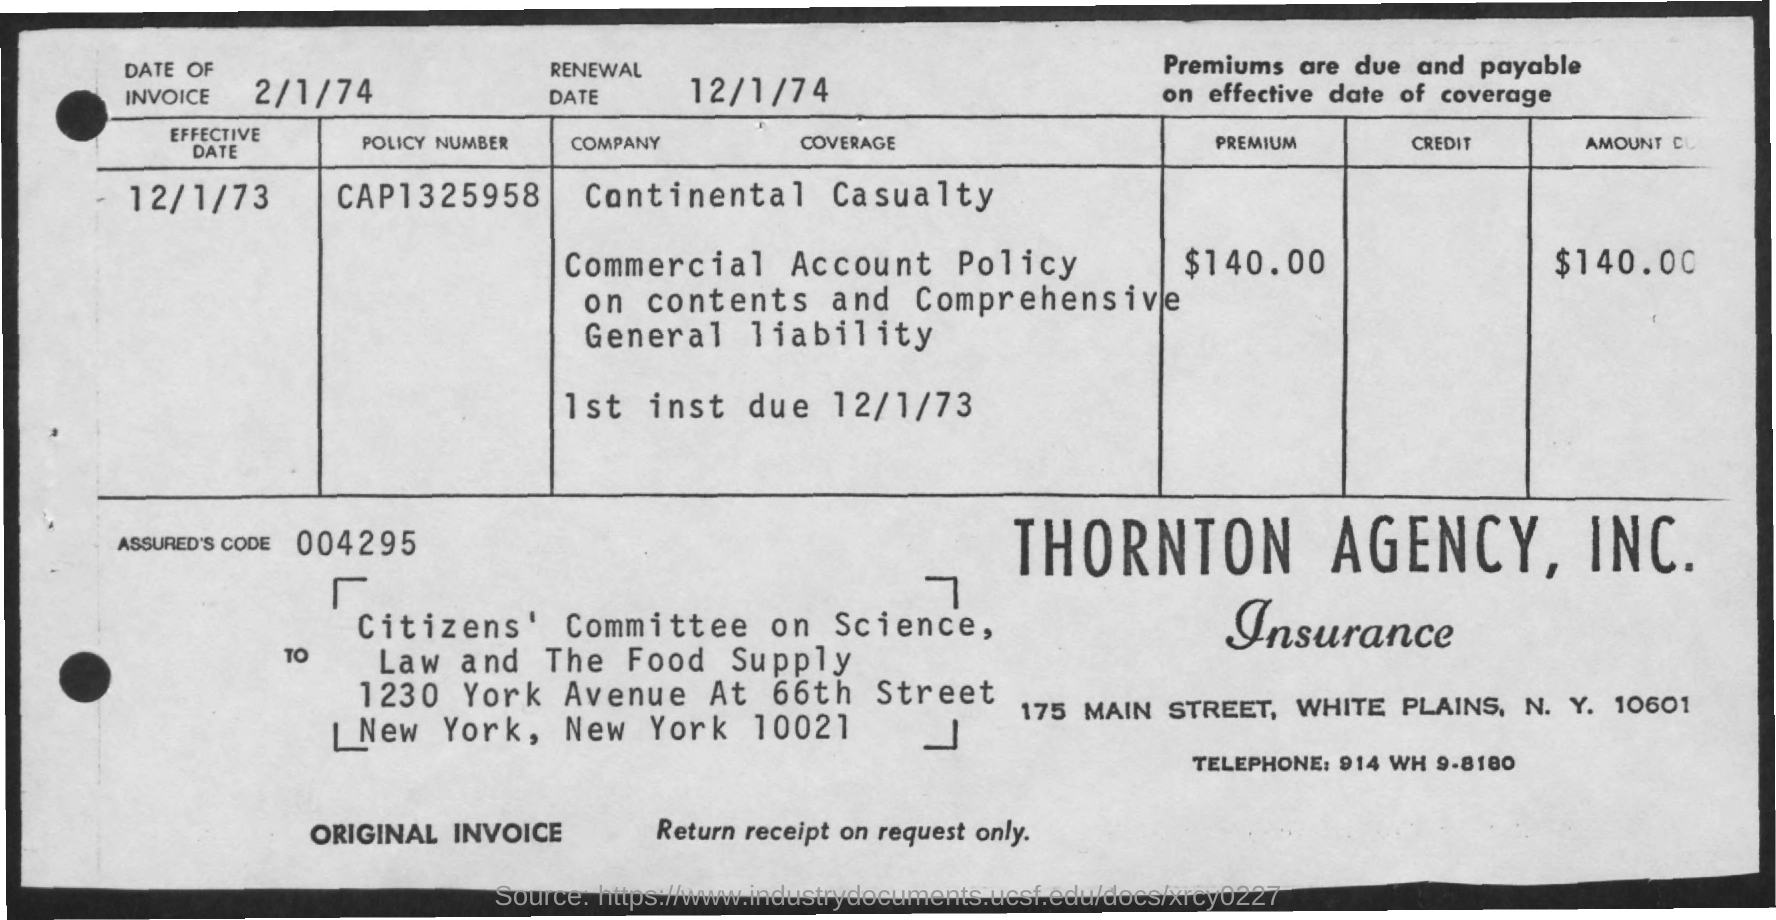Draw attention to some important aspects in this diagram. What is the policy number? CAP1325958... Continental Casualty is the company that pays the premium. The premium amount to be paid is $140.00. What is the code for the ASSURED'S device? The code is 004295... The telephone number is 914 WH 9-8180. 